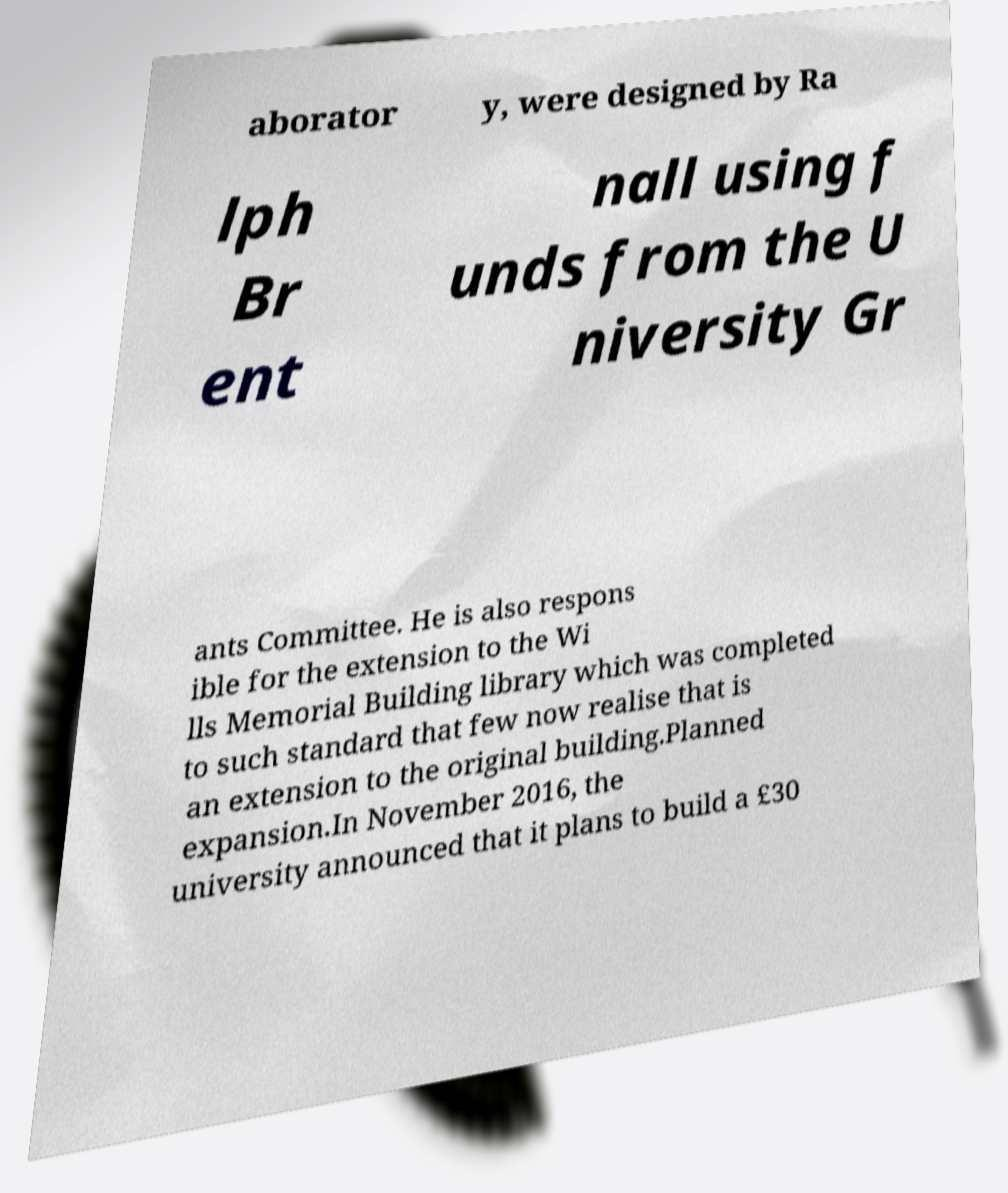For documentation purposes, I need the text within this image transcribed. Could you provide that? aborator y, were designed by Ra lph Br ent nall using f unds from the U niversity Gr ants Committee. He is also respons ible for the extension to the Wi lls Memorial Building library which was completed to such standard that few now realise that is an extension to the original building.Planned expansion.In November 2016, the university announced that it plans to build a £30 